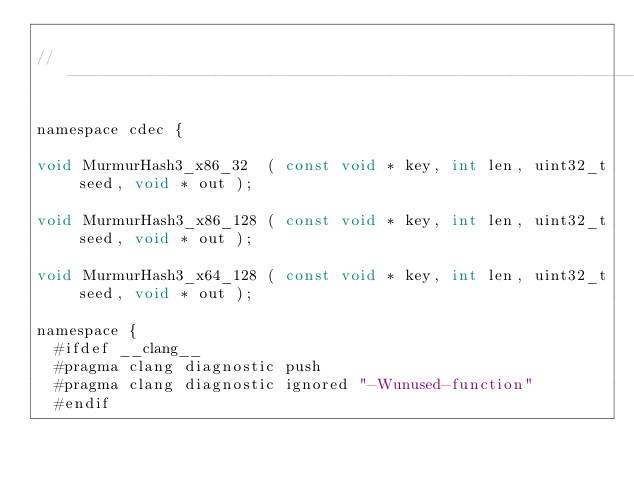Convert code to text. <code><loc_0><loc_0><loc_500><loc_500><_C_>
//-----------------------------------------------------------------------------

namespace cdec {

void MurmurHash3_x86_32  ( const void * key, int len, uint32_t seed, void * out );

void MurmurHash3_x86_128 ( const void * key, int len, uint32_t seed, void * out );

void MurmurHash3_x64_128 ( const void * key, int len, uint32_t seed, void * out );

namespace {
  #ifdef __clang__
  #pragma clang diagnostic push
  #pragma clang diagnostic ignored "-Wunused-function"
  #endif</code> 